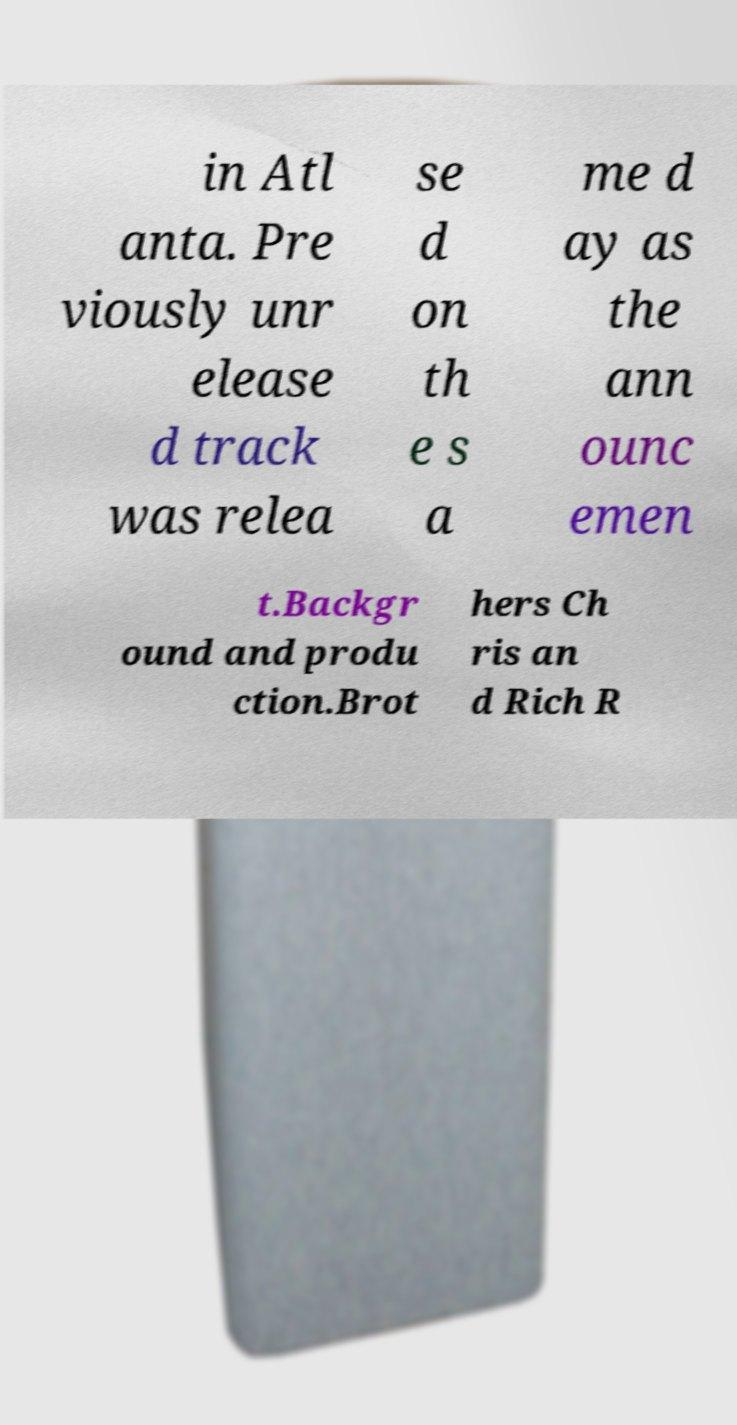Please identify and transcribe the text found in this image. in Atl anta. Pre viously unr elease d track was relea se d on th e s a me d ay as the ann ounc emen t.Backgr ound and produ ction.Brot hers Ch ris an d Rich R 